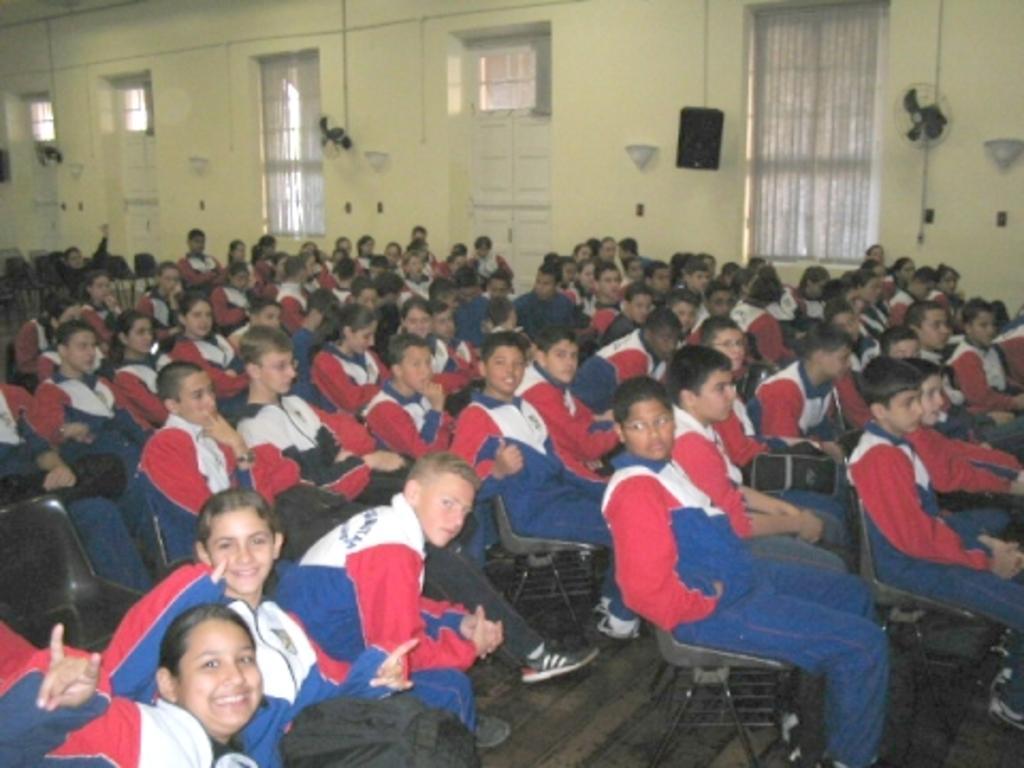Describe this image in one or two sentences. In this image in the middle, there is a boy, he wears a t shirt, trouser, he is sitting on the chair. In the middle there is a girl, she wears a t shirt, trouser, she is smiling, in front of her there is a woman, she wears a t shirt. On the right there is a boy, he wears a t shirt, trouser, he is sitting. In the middle there are many people, they are sitting on chairs. In the background there are doors, windows, curtains, speakers, fan, lights and wall. 